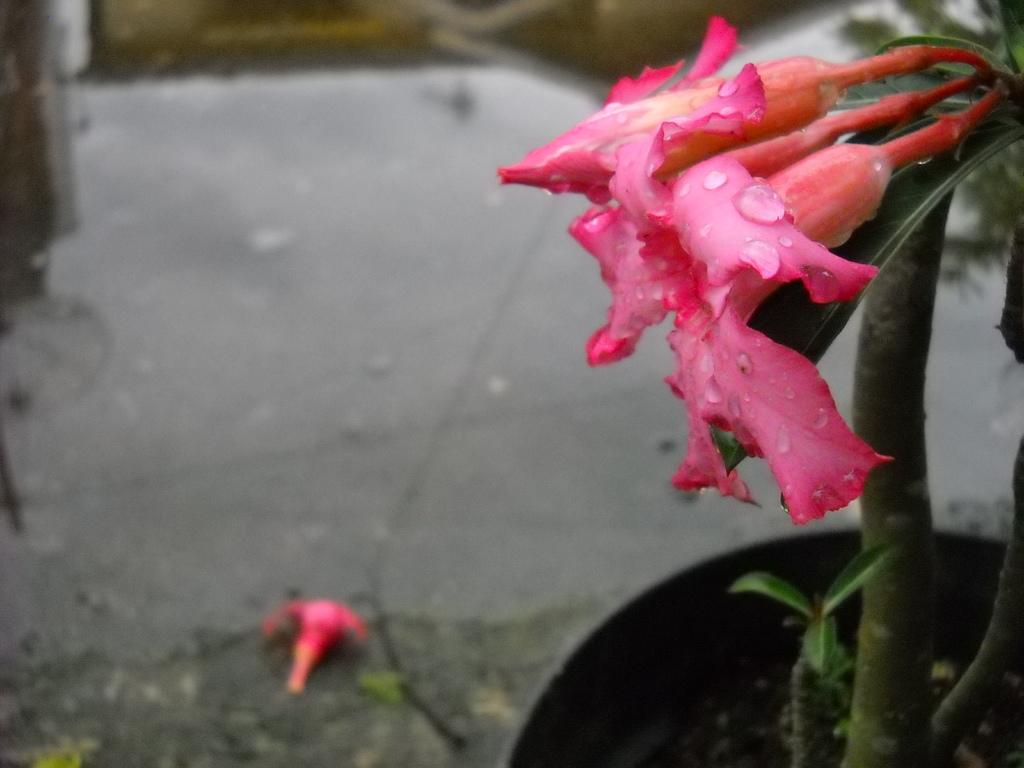What type of flowers are present in the image? There are pink flowers in the image. What other plant can be seen in the image? There is a house plant in the image. Can you describe the background of the image? The background of the image is blurred. Where is the shelf located in the image? There is no shelf present in the image. How does the sun affect the growth of the flowers in the image? The image does not show the sun or its effect on the flowers, so we cannot determine how it affects their growth. 